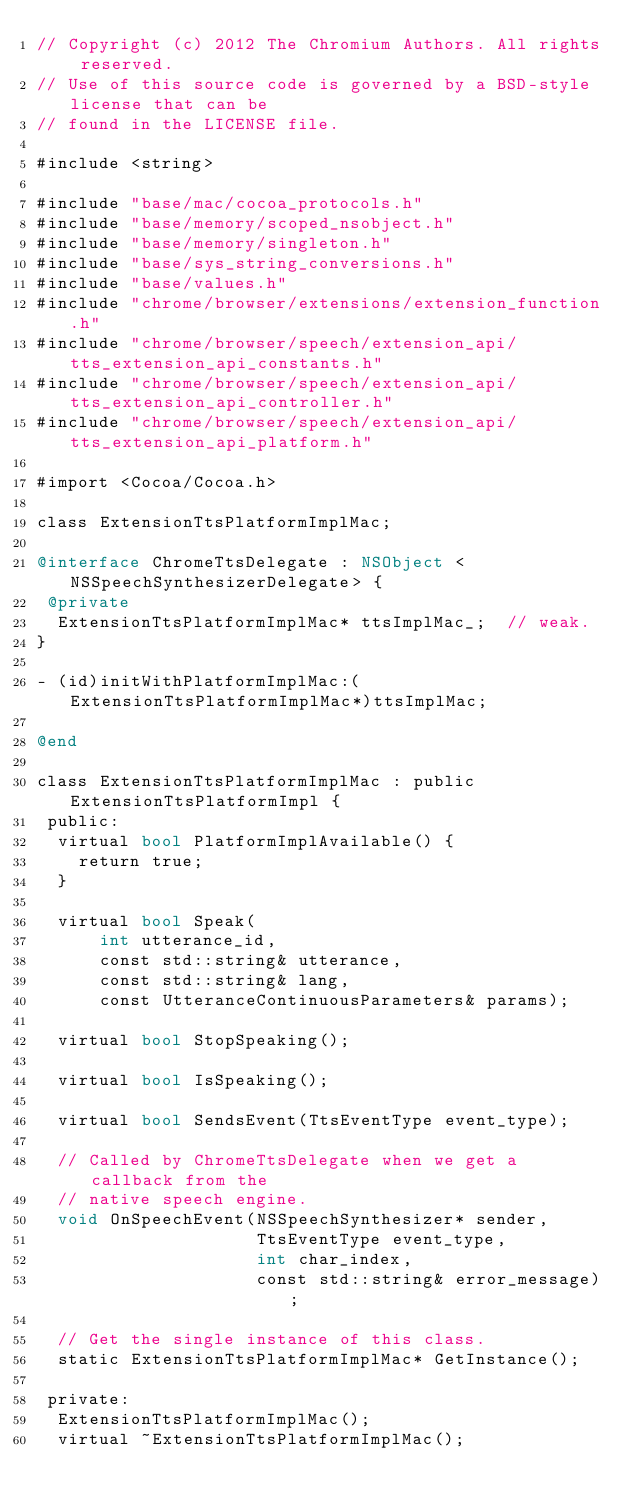Convert code to text. <code><loc_0><loc_0><loc_500><loc_500><_ObjectiveC_>// Copyright (c) 2012 The Chromium Authors. All rights reserved.
// Use of this source code is governed by a BSD-style license that can be
// found in the LICENSE file.

#include <string>

#include "base/mac/cocoa_protocols.h"
#include "base/memory/scoped_nsobject.h"
#include "base/memory/singleton.h"
#include "base/sys_string_conversions.h"
#include "base/values.h"
#include "chrome/browser/extensions/extension_function.h"
#include "chrome/browser/speech/extension_api/tts_extension_api_constants.h"
#include "chrome/browser/speech/extension_api/tts_extension_api_controller.h"
#include "chrome/browser/speech/extension_api/tts_extension_api_platform.h"

#import <Cocoa/Cocoa.h>

class ExtensionTtsPlatformImplMac;

@interface ChromeTtsDelegate : NSObject <NSSpeechSynthesizerDelegate> {
 @private
  ExtensionTtsPlatformImplMac* ttsImplMac_;  // weak.
}

- (id)initWithPlatformImplMac:(ExtensionTtsPlatformImplMac*)ttsImplMac;

@end

class ExtensionTtsPlatformImplMac : public ExtensionTtsPlatformImpl {
 public:
  virtual bool PlatformImplAvailable() {
    return true;
  }

  virtual bool Speak(
      int utterance_id,
      const std::string& utterance,
      const std::string& lang,
      const UtteranceContinuousParameters& params);

  virtual bool StopSpeaking();

  virtual bool IsSpeaking();

  virtual bool SendsEvent(TtsEventType event_type);

  // Called by ChromeTtsDelegate when we get a callback from the
  // native speech engine.
  void OnSpeechEvent(NSSpeechSynthesizer* sender,
                     TtsEventType event_type,
                     int char_index,
                     const std::string& error_message);

  // Get the single instance of this class.
  static ExtensionTtsPlatformImplMac* GetInstance();

 private:
  ExtensionTtsPlatformImplMac();
  virtual ~ExtensionTtsPlatformImplMac();
</code> 